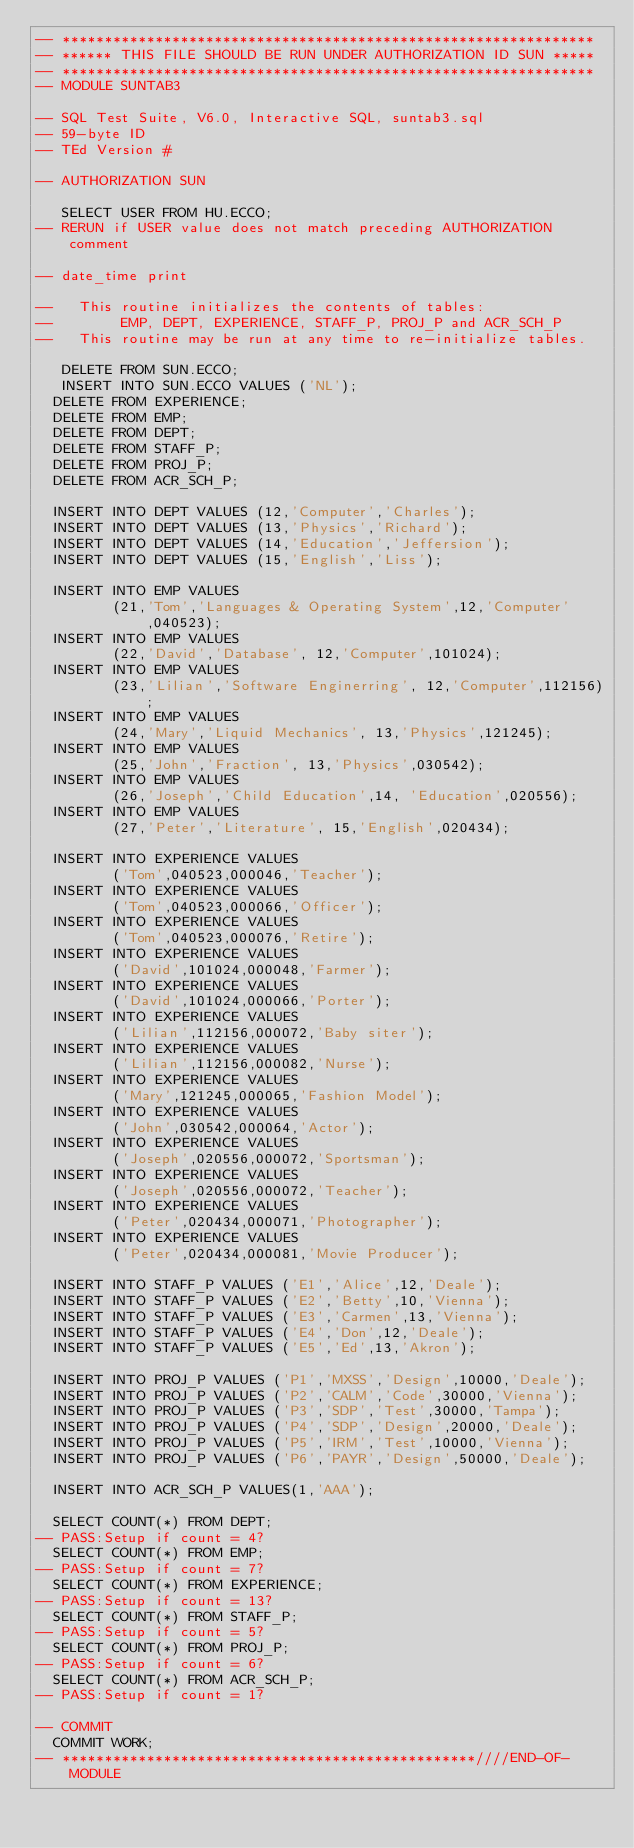<code> <loc_0><loc_0><loc_500><loc_500><_SQL_>-- ***************************************************************
-- ****** THIS FILE SHOULD BE RUN UNDER AUTHORIZATION ID SUN *****
-- ***************************************************************
-- MODULE SUNTAB3

-- SQL Test Suite, V6.0, Interactive SQL, suntab3.sql
-- 59-byte ID
-- TEd Version #

-- AUTHORIZATION SUN

   SELECT USER FROM HU.ECCO;
-- RERUN if USER value does not match preceding AUTHORIZATION comment

-- date_time print

--   This routine initializes the contents of tables:
--        EMP, DEPT, EXPERIENCE, STAFF_P, PROJ_P and ACR_SCH_P
--   This routine may be run at any time to re-initialize tables.

   DELETE FROM SUN.ECCO;
   INSERT INTO SUN.ECCO VALUES ('NL');
  DELETE FROM EXPERIENCE;
  DELETE FROM EMP;
  DELETE FROM DEPT;
  DELETE FROM STAFF_P;
  DELETE FROM PROJ_P;
  DELETE FROM ACR_SCH_P;

  INSERT INTO DEPT VALUES (12,'Computer','Charles');
  INSERT INTO DEPT VALUES (13,'Physics','Richard');
  INSERT INTO DEPT VALUES (14,'Education','Jeffersion');
  INSERT INTO DEPT VALUES (15,'English','Liss');

  INSERT INTO EMP VALUES  
         (21,'Tom','Languages & Operating System',12,'Computer',040523);
  INSERT INTO EMP VALUES  
         (22,'David','Database', 12,'Computer',101024);
  INSERT INTO EMP VALUES  
         (23,'Lilian','Software Enginerring', 12,'Computer',112156);
  INSERT INTO EMP VALUES  
         (24,'Mary','Liquid Mechanics', 13,'Physics',121245);
  INSERT INTO EMP VALUES  
         (25,'John','Fraction', 13,'Physics',030542);
  INSERT INTO EMP VALUES  
         (26,'Joseph','Child Education',14, 'Education',020556);
  INSERT INTO EMP VALUES  
         (27,'Peter','Literature', 15,'English',020434);

  INSERT INTO EXPERIENCE VALUES 
         ('Tom',040523,000046,'Teacher');
  INSERT INTO EXPERIENCE VALUES 
         ('Tom',040523,000066,'Officer');
  INSERT INTO EXPERIENCE VALUES 
         ('Tom',040523,000076,'Retire');
  INSERT INTO EXPERIENCE VALUES 
         ('David',101024,000048,'Farmer');
  INSERT INTO EXPERIENCE VALUES 
         ('David',101024,000066,'Porter');
  INSERT INTO EXPERIENCE VALUES 
         ('Lilian',112156,000072,'Baby siter');
  INSERT INTO EXPERIENCE VALUES 
         ('Lilian',112156,000082,'Nurse');
  INSERT INTO EXPERIENCE VALUES 
         ('Mary',121245,000065,'Fashion Model');
  INSERT INTO EXPERIENCE VALUES 
         ('John',030542,000064,'Actor');
  INSERT INTO EXPERIENCE VALUES 
         ('Joseph',020556,000072,'Sportsman');
  INSERT INTO EXPERIENCE VALUES 
         ('Joseph',020556,000072,'Teacher');
  INSERT INTO EXPERIENCE VALUES 
         ('Peter',020434,000071,'Photographer');
  INSERT INTO EXPERIENCE VALUES 
         ('Peter',020434,000081,'Movie Producer');

  INSERT INTO STAFF_P VALUES ('E1','Alice',12,'Deale');
  INSERT INTO STAFF_P VALUES ('E2','Betty',10,'Vienna');
  INSERT INTO STAFF_P VALUES ('E3','Carmen',13,'Vienna');
  INSERT INTO STAFF_P VALUES ('E4','Don',12,'Deale');
  INSERT INTO STAFF_P VALUES ('E5','Ed',13,'Akron');

  INSERT INTO PROJ_P VALUES ('P1','MXSS','Design',10000,'Deale');
  INSERT INTO PROJ_P VALUES ('P2','CALM','Code',30000,'Vienna');
  INSERT INTO PROJ_P VALUES ('P3','SDP','Test',30000,'Tampa');
  INSERT INTO PROJ_P VALUES ('P4','SDP','Design',20000,'Deale');
  INSERT INTO PROJ_P VALUES ('P5','IRM','Test',10000,'Vienna');
  INSERT INTO PROJ_P VALUES ('P6','PAYR','Design',50000,'Deale');

  INSERT INTO ACR_SCH_P VALUES(1,'AAA');

  SELECT COUNT(*) FROM DEPT;
-- PASS:Setup if count = 4?
  SELECT COUNT(*) FROM EMP;
-- PASS:Setup if count = 7?
  SELECT COUNT(*) FROM EXPERIENCE;
-- PASS:Setup if count = 13?
  SELECT COUNT(*) FROM STAFF_P;
-- PASS:Setup if count = 5?
  SELECT COUNT(*) FROM PROJ_P;
-- PASS:Setup if count = 6?
  SELECT COUNT(*) FROM ACR_SCH_P;
-- PASS:Setup if count = 1?

-- COMMIT
  COMMIT WORK;
-- *************************************************////END-OF-MODULE
</code> 